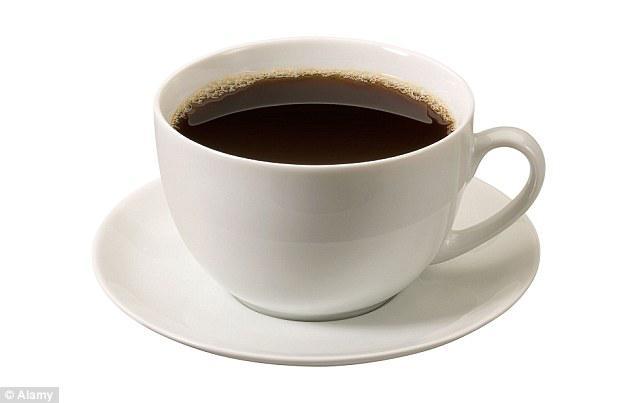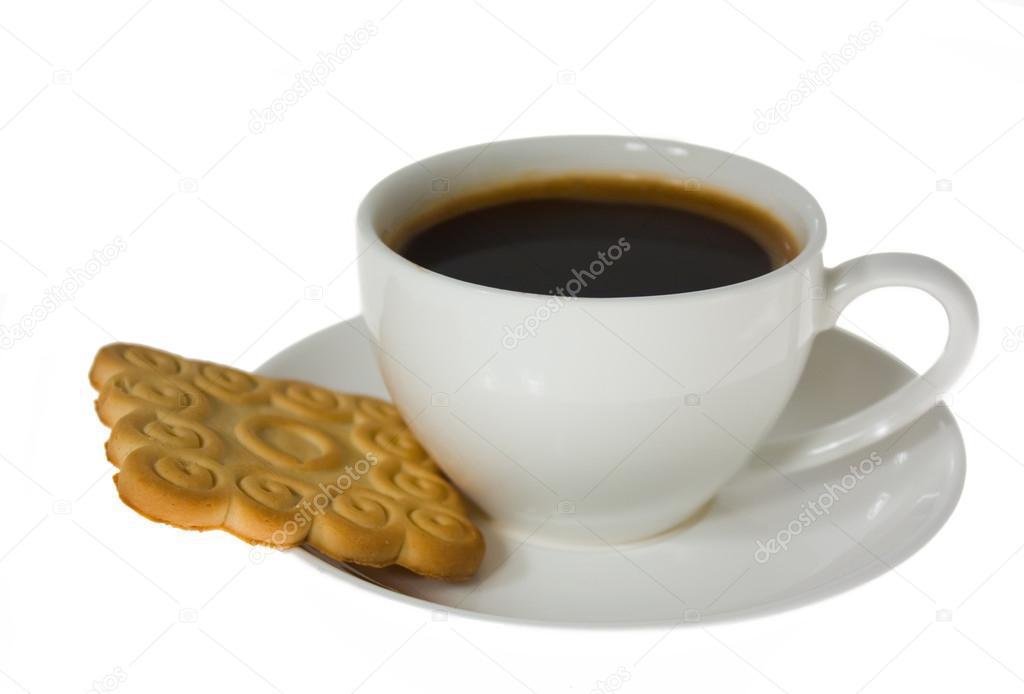The first image is the image on the left, the second image is the image on the right. Analyze the images presented: Is the assertion "There are at least three coffee cups in the left image." valid? Answer yes or no. No. The first image is the image on the left, the second image is the image on the right. Assess this claim about the two images: "There are three mugs filled with a cafe drink in the image on the left.". Correct or not? Answer yes or no. No. 